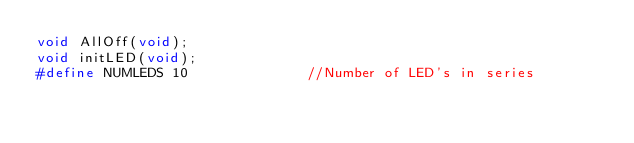<code> <loc_0><loc_0><loc_500><loc_500><_C_>void AllOff(void);
void initLED(void);
#define NUMLEDS 10              //Number of LED's in series</code> 